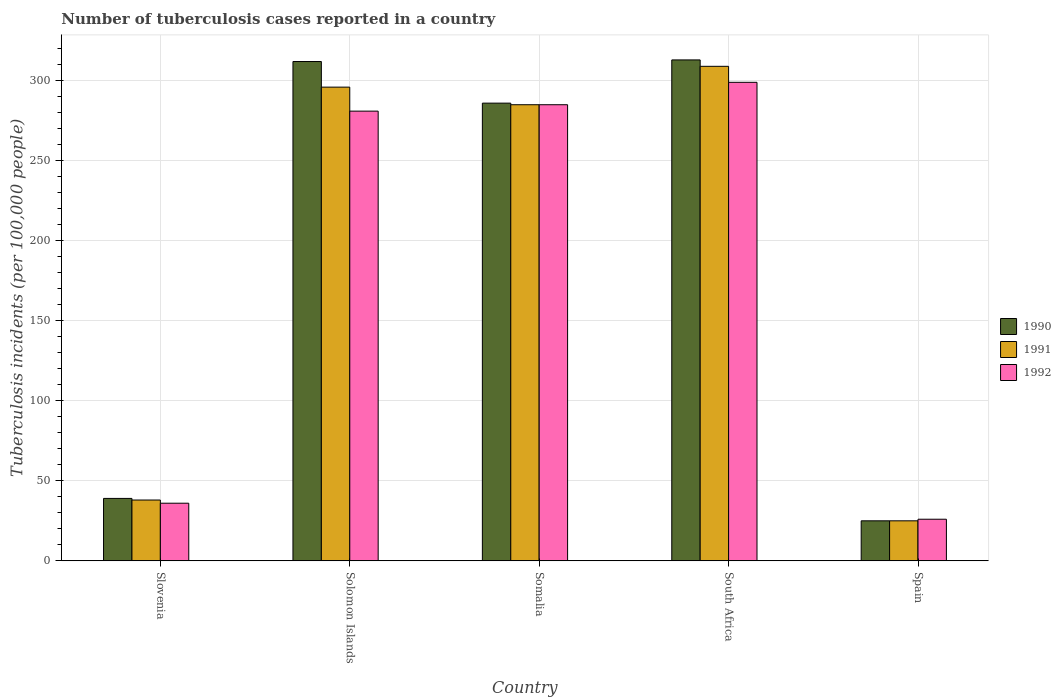How many different coloured bars are there?
Your response must be concise. 3. Are the number of bars on each tick of the X-axis equal?
Your answer should be very brief. Yes. How many bars are there on the 5th tick from the left?
Provide a succinct answer. 3. How many bars are there on the 4th tick from the right?
Provide a short and direct response. 3. In how many cases, is the number of bars for a given country not equal to the number of legend labels?
Provide a succinct answer. 0. What is the number of tuberculosis cases reported in in 1990 in Somalia?
Your response must be concise. 286. Across all countries, what is the maximum number of tuberculosis cases reported in in 1990?
Provide a succinct answer. 313. Across all countries, what is the minimum number of tuberculosis cases reported in in 1991?
Provide a succinct answer. 25. In which country was the number of tuberculosis cases reported in in 1990 maximum?
Your answer should be very brief. South Africa. What is the total number of tuberculosis cases reported in in 1992 in the graph?
Provide a short and direct response. 927. What is the difference between the number of tuberculosis cases reported in in 1990 in Spain and the number of tuberculosis cases reported in in 1992 in Slovenia?
Offer a very short reply. -11. What is the average number of tuberculosis cases reported in in 1992 per country?
Give a very brief answer. 185.4. What is the ratio of the number of tuberculosis cases reported in in 1990 in Somalia to that in Spain?
Provide a short and direct response. 11.44. Is the difference between the number of tuberculosis cases reported in in 1990 in Solomon Islands and Somalia greater than the difference between the number of tuberculosis cases reported in in 1992 in Solomon Islands and Somalia?
Keep it short and to the point. Yes. What is the difference between the highest and the lowest number of tuberculosis cases reported in in 1992?
Your answer should be compact. 273. In how many countries, is the number of tuberculosis cases reported in in 1990 greater than the average number of tuberculosis cases reported in in 1990 taken over all countries?
Make the answer very short. 3. What does the 1st bar from the left in Solomon Islands represents?
Make the answer very short. 1990. Are all the bars in the graph horizontal?
Give a very brief answer. No. Does the graph contain grids?
Provide a short and direct response. Yes. Where does the legend appear in the graph?
Your response must be concise. Center right. How are the legend labels stacked?
Your answer should be very brief. Vertical. What is the title of the graph?
Provide a succinct answer. Number of tuberculosis cases reported in a country. What is the label or title of the Y-axis?
Keep it short and to the point. Tuberculosis incidents (per 100,0 people). What is the Tuberculosis incidents (per 100,000 people) in 1990 in Slovenia?
Give a very brief answer. 39. What is the Tuberculosis incidents (per 100,000 people) in 1992 in Slovenia?
Your response must be concise. 36. What is the Tuberculosis incidents (per 100,000 people) in 1990 in Solomon Islands?
Provide a succinct answer. 312. What is the Tuberculosis incidents (per 100,000 people) in 1991 in Solomon Islands?
Offer a terse response. 296. What is the Tuberculosis incidents (per 100,000 people) of 1992 in Solomon Islands?
Give a very brief answer. 281. What is the Tuberculosis incidents (per 100,000 people) of 1990 in Somalia?
Your answer should be very brief. 286. What is the Tuberculosis incidents (per 100,000 people) in 1991 in Somalia?
Your response must be concise. 285. What is the Tuberculosis incidents (per 100,000 people) in 1992 in Somalia?
Make the answer very short. 285. What is the Tuberculosis incidents (per 100,000 people) in 1990 in South Africa?
Your response must be concise. 313. What is the Tuberculosis incidents (per 100,000 people) of 1991 in South Africa?
Your answer should be compact. 309. What is the Tuberculosis incidents (per 100,000 people) in 1992 in South Africa?
Your response must be concise. 299. What is the Tuberculosis incidents (per 100,000 people) in 1991 in Spain?
Your answer should be very brief. 25. Across all countries, what is the maximum Tuberculosis incidents (per 100,000 people) of 1990?
Keep it short and to the point. 313. Across all countries, what is the maximum Tuberculosis incidents (per 100,000 people) in 1991?
Give a very brief answer. 309. Across all countries, what is the maximum Tuberculosis incidents (per 100,000 people) in 1992?
Your answer should be compact. 299. What is the total Tuberculosis incidents (per 100,000 people) of 1990 in the graph?
Keep it short and to the point. 975. What is the total Tuberculosis incidents (per 100,000 people) in 1991 in the graph?
Offer a very short reply. 953. What is the total Tuberculosis incidents (per 100,000 people) in 1992 in the graph?
Make the answer very short. 927. What is the difference between the Tuberculosis incidents (per 100,000 people) in 1990 in Slovenia and that in Solomon Islands?
Your response must be concise. -273. What is the difference between the Tuberculosis incidents (per 100,000 people) in 1991 in Slovenia and that in Solomon Islands?
Provide a short and direct response. -258. What is the difference between the Tuberculosis incidents (per 100,000 people) in 1992 in Slovenia and that in Solomon Islands?
Ensure brevity in your answer.  -245. What is the difference between the Tuberculosis incidents (per 100,000 people) in 1990 in Slovenia and that in Somalia?
Your answer should be compact. -247. What is the difference between the Tuberculosis incidents (per 100,000 people) of 1991 in Slovenia and that in Somalia?
Your answer should be compact. -247. What is the difference between the Tuberculosis incidents (per 100,000 people) of 1992 in Slovenia and that in Somalia?
Ensure brevity in your answer.  -249. What is the difference between the Tuberculosis incidents (per 100,000 people) in 1990 in Slovenia and that in South Africa?
Your response must be concise. -274. What is the difference between the Tuberculosis incidents (per 100,000 people) in 1991 in Slovenia and that in South Africa?
Give a very brief answer. -271. What is the difference between the Tuberculosis incidents (per 100,000 people) of 1992 in Slovenia and that in South Africa?
Keep it short and to the point. -263. What is the difference between the Tuberculosis incidents (per 100,000 people) of 1990 in Slovenia and that in Spain?
Your response must be concise. 14. What is the difference between the Tuberculosis incidents (per 100,000 people) of 1991 in Slovenia and that in Spain?
Provide a short and direct response. 13. What is the difference between the Tuberculosis incidents (per 100,000 people) of 1992 in Slovenia and that in Spain?
Ensure brevity in your answer.  10. What is the difference between the Tuberculosis incidents (per 100,000 people) of 1990 in Solomon Islands and that in Somalia?
Provide a succinct answer. 26. What is the difference between the Tuberculosis incidents (per 100,000 people) of 1991 in Solomon Islands and that in Somalia?
Ensure brevity in your answer.  11. What is the difference between the Tuberculosis incidents (per 100,000 people) of 1992 in Solomon Islands and that in Somalia?
Keep it short and to the point. -4. What is the difference between the Tuberculosis incidents (per 100,000 people) in 1990 in Solomon Islands and that in Spain?
Give a very brief answer. 287. What is the difference between the Tuberculosis incidents (per 100,000 people) of 1991 in Solomon Islands and that in Spain?
Your answer should be very brief. 271. What is the difference between the Tuberculosis incidents (per 100,000 people) in 1992 in Solomon Islands and that in Spain?
Your answer should be compact. 255. What is the difference between the Tuberculosis incidents (per 100,000 people) of 1991 in Somalia and that in South Africa?
Offer a very short reply. -24. What is the difference between the Tuberculosis incidents (per 100,000 people) in 1990 in Somalia and that in Spain?
Keep it short and to the point. 261. What is the difference between the Tuberculosis incidents (per 100,000 people) in 1991 in Somalia and that in Spain?
Provide a succinct answer. 260. What is the difference between the Tuberculosis incidents (per 100,000 people) of 1992 in Somalia and that in Spain?
Offer a very short reply. 259. What is the difference between the Tuberculosis incidents (per 100,000 people) of 1990 in South Africa and that in Spain?
Give a very brief answer. 288. What is the difference between the Tuberculosis incidents (per 100,000 people) in 1991 in South Africa and that in Spain?
Provide a succinct answer. 284. What is the difference between the Tuberculosis incidents (per 100,000 people) of 1992 in South Africa and that in Spain?
Keep it short and to the point. 273. What is the difference between the Tuberculosis incidents (per 100,000 people) in 1990 in Slovenia and the Tuberculosis incidents (per 100,000 people) in 1991 in Solomon Islands?
Offer a very short reply. -257. What is the difference between the Tuberculosis incidents (per 100,000 people) in 1990 in Slovenia and the Tuberculosis incidents (per 100,000 people) in 1992 in Solomon Islands?
Offer a very short reply. -242. What is the difference between the Tuberculosis incidents (per 100,000 people) of 1991 in Slovenia and the Tuberculosis incidents (per 100,000 people) of 1992 in Solomon Islands?
Ensure brevity in your answer.  -243. What is the difference between the Tuberculosis incidents (per 100,000 people) in 1990 in Slovenia and the Tuberculosis incidents (per 100,000 people) in 1991 in Somalia?
Offer a terse response. -246. What is the difference between the Tuberculosis incidents (per 100,000 people) in 1990 in Slovenia and the Tuberculosis incidents (per 100,000 people) in 1992 in Somalia?
Provide a short and direct response. -246. What is the difference between the Tuberculosis incidents (per 100,000 people) of 1991 in Slovenia and the Tuberculosis incidents (per 100,000 people) of 1992 in Somalia?
Your answer should be very brief. -247. What is the difference between the Tuberculosis incidents (per 100,000 people) in 1990 in Slovenia and the Tuberculosis incidents (per 100,000 people) in 1991 in South Africa?
Offer a very short reply. -270. What is the difference between the Tuberculosis incidents (per 100,000 people) in 1990 in Slovenia and the Tuberculosis incidents (per 100,000 people) in 1992 in South Africa?
Offer a terse response. -260. What is the difference between the Tuberculosis incidents (per 100,000 people) in 1991 in Slovenia and the Tuberculosis incidents (per 100,000 people) in 1992 in South Africa?
Give a very brief answer. -261. What is the difference between the Tuberculosis incidents (per 100,000 people) of 1990 in Solomon Islands and the Tuberculosis incidents (per 100,000 people) of 1992 in Somalia?
Your response must be concise. 27. What is the difference between the Tuberculosis incidents (per 100,000 people) in 1991 in Solomon Islands and the Tuberculosis incidents (per 100,000 people) in 1992 in Somalia?
Offer a very short reply. 11. What is the difference between the Tuberculosis incidents (per 100,000 people) in 1990 in Solomon Islands and the Tuberculosis incidents (per 100,000 people) in 1991 in South Africa?
Offer a terse response. 3. What is the difference between the Tuberculosis incidents (per 100,000 people) in 1990 in Solomon Islands and the Tuberculosis incidents (per 100,000 people) in 1992 in South Africa?
Keep it short and to the point. 13. What is the difference between the Tuberculosis incidents (per 100,000 people) of 1990 in Solomon Islands and the Tuberculosis incidents (per 100,000 people) of 1991 in Spain?
Ensure brevity in your answer.  287. What is the difference between the Tuberculosis incidents (per 100,000 people) of 1990 in Solomon Islands and the Tuberculosis incidents (per 100,000 people) of 1992 in Spain?
Ensure brevity in your answer.  286. What is the difference between the Tuberculosis incidents (per 100,000 people) of 1991 in Solomon Islands and the Tuberculosis incidents (per 100,000 people) of 1992 in Spain?
Your answer should be compact. 270. What is the difference between the Tuberculosis incidents (per 100,000 people) in 1990 in Somalia and the Tuberculosis incidents (per 100,000 people) in 1991 in South Africa?
Your answer should be compact. -23. What is the difference between the Tuberculosis incidents (per 100,000 people) of 1990 in Somalia and the Tuberculosis incidents (per 100,000 people) of 1991 in Spain?
Give a very brief answer. 261. What is the difference between the Tuberculosis incidents (per 100,000 people) of 1990 in Somalia and the Tuberculosis incidents (per 100,000 people) of 1992 in Spain?
Ensure brevity in your answer.  260. What is the difference between the Tuberculosis incidents (per 100,000 people) of 1991 in Somalia and the Tuberculosis incidents (per 100,000 people) of 1992 in Spain?
Your response must be concise. 259. What is the difference between the Tuberculosis incidents (per 100,000 people) in 1990 in South Africa and the Tuberculosis incidents (per 100,000 people) in 1991 in Spain?
Offer a very short reply. 288. What is the difference between the Tuberculosis incidents (per 100,000 people) of 1990 in South Africa and the Tuberculosis incidents (per 100,000 people) of 1992 in Spain?
Provide a short and direct response. 287. What is the difference between the Tuberculosis incidents (per 100,000 people) of 1991 in South Africa and the Tuberculosis incidents (per 100,000 people) of 1992 in Spain?
Your response must be concise. 283. What is the average Tuberculosis incidents (per 100,000 people) of 1990 per country?
Give a very brief answer. 195. What is the average Tuberculosis incidents (per 100,000 people) in 1991 per country?
Your answer should be compact. 190.6. What is the average Tuberculosis incidents (per 100,000 people) of 1992 per country?
Ensure brevity in your answer.  185.4. What is the difference between the Tuberculosis incidents (per 100,000 people) in 1990 and Tuberculosis incidents (per 100,000 people) in 1991 in Slovenia?
Your answer should be very brief. 1. What is the difference between the Tuberculosis incidents (per 100,000 people) of 1990 and Tuberculosis incidents (per 100,000 people) of 1991 in Solomon Islands?
Ensure brevity in your answer.  16. What is the difference between the Tuberculosis incidents (per 100,000 people) of 1990 and Tuberculosis incidents (per 100,000 people) of 1991 in Somalia?
Offer a very short reply. 1. What is the difference between the Tuberculosis incidents (per 100,000 people) in 1990 and Tuberculosis incidents (per 100,000 people) in 1991 in South Africa?
Offer a very short reply. 4. What is the difference between the Tuberculosis incidents (per 100,000 people) in 1990 and Tuberculosis incidents (per 100,000 people) in 1992 in South Africa?
Make the answer very short. 14. What is the difference between the Tuberculosis incidents (per 100,000 people) in 1991 and Tuberculosis incidents (per 100,000 people) in 1992 in South Africa?
Provide a short and direct response. 10. What is the ratio of the Tuberculosis incidents (per 100,000 people) in 1990 in Slovenia to that in Solomon Islands?
Your response must be concise. 0.12. What is the ratio of the Tuberculosis incidents (per 100,000 people) of 1991 in Slovenia to that in Solomon Islands?
Give a very brief answer. 0.13. What is the ratio of the Tuberculosis incidents (per 100,000 people) in 1992 in Slovenia to that in Solomon Islands?
Your answer should be compact. 0.13. What is the ratio of the Tuberculosis incidents (per 100,000 people) in 1990 in Slovenia to that in Somalia?
Give a very brief answer. 0.14. What is the ratio of the Tuberculosis incidents (per 100,000 people) of 1991 in Slovenia to that in Somalia?
Ensure brevity in your answer.  0.13. What is the ratio of the Tuberculosis incidents (per 100,000 people) in 1992 in Slovenia to that in Somalia?
Your answer should be very brief. 0.13. What is the ratio of the Tuberculosis incidents (per 100,000 people) of 1990 in Slovenia to that in South Africa?
Give a very brief answer. 0.12. What is the ratio of the Tuberculosis incidents (per 100,000 people) of 1991 in Slovenia to that in South Africa?
Keep it short and to the point. 0.12. What is the ratio of the Tuberculosis incidents (per 100,000 people) of 1992 in Slovenia to that in South Africa?
Give a very brief answer. 0.12. What is the ratio of the Tuberculosis incidents (per 100,000 people) of 1990 in Slovenia to that in Spain?
Your answer should be very brief. 1.56. What is the ratio of the Tuberculosis incidents (per 100,000 people) in 1991 in Slovenia to that in Spain?
Your response must be concise. 1.52. What is the ratio of the Tuberculosis incidents (per 100,000 people) of 1992 in Slovenia to that in Spain?
Give a very brief answer. 1.38. What is the ratio of the Tuberculosis incidents (per 100,000 people) of 1991 in Solomon Islands to that in Somalia?
Provide a short and direct response. 1.04. What is the ratio of the Tuberculosis incidents (per 100,000 people) in 1990 in Solomon Islands to that in South Africa?
Make the answer very short. 1. What is the ratio of the Tuberculosis incidents (per 100,000 people) of 1991 in Solomon Islands to that in South Africa?
Ensure brevity in your answer.  0.96. What is the ratio of the Tuberculosis incidents (per 100,000 people) of 1992 in Solomon Islands to that in South Africa?
Ensure brevity in your answer.  0.94. What is the ratio of the Tuberculosis incidents (per 100,000 people) in 1990 in Solomon Islands to that in Spain?
Ensure brevity in your answer.  12.48. What is the ratio of the Tuberculosis incidents (per 100,000 people) of 1991 in Solomon Islands to that in Spain?
Keep it short and to the point. 11.84. What is the ratio of the Tuberculosis incidents (per 100,000 people) in 1992 in Solomon Islands to that in Spain?
Your response must be concise. 10.81. What is the ratio of the Tuberculosis incidents (per 100,000 people) of 1990 in Somalia to that in South Africa?
Provide a short and direct response. 0.91. What is the ratio of the Tuberculosis incidents (per 100,000 people) in 1991 in Somalia to that in South Africa?
Give a very brief answer. 0.92. What is the ratio of the Tuberculosis incidents (per 100,000 people) in 1992 in Somalia to that in South Africa?
Offer a very short reply. 0.95. What is the ratio of the Tuberculosis incidents (per 100,000 people) of 1990 in Somalia to that in Spain?
Offer a very short reply. 11.44. What is the ratio of the Tuberculosis incidents (per 100,000 people) of 1992 in Somalia to that in Spain?
Make the answer very short. 10.96. What is the ratio of the Tuberculosis incidents (per 100,000 people) in 1990 in South Africa to that in Spain?
Offer a terse response. 12.52. What is the ratio of the Tuberculosis incidents (per 100,000 people) in 1991 in South Africa to that in Spain?
Your response must be concise. 12.36. What is the ratio of the Tuberculosis incidents (per 100,000 people) of 1992 in South Africa to that in Spain?
Keep it short and to the point. 11.5. What is the difference between the highest and the second highest Tuberculosis incidents (per 100,000 people) of 1990?
Ensure brevity in your answer.  1. What is the difference between the highest and the second highest Tuberculosis incidents (per 100,000 people) of 1991?
Provide a short and direct response. 13. What is the difference between the highest and the lowest Tuberculosis incidents (per 100,000 people) in 1990?
Ensure brevity in your answer.  288. What is the difference between the highest and the lowest Tuberculosis incidents (per 100,000 people) in 1991?
Provide a succinct answer. 284. What is the difference between the highest and the lowest Tuberculosis incidents (per 100,000 people) in 1992?
Your answer should be compact. 273. 